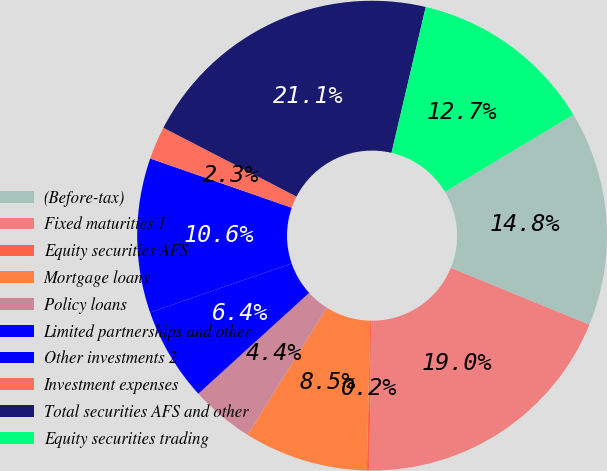<chart> <loc_0><loc_0><loc_500><loc_500><pie_chart><fcel>(Before-tax)<fcel>Fixed maturities 1<fcel>Equity securities AFS<fcel>Mortgage loans<fcel>Policy loans<fcel>Limited partnerships and other<fcel>Other investments 2<fcel>Investment expenses<fcel>Total securities AFS and other<fcel>Equity securities trading<nl><fcel>14.81%<fcel>18.99%<fcel>0.18%<fcel>8.54%<fcel>4.36%<fcel>6.45%<fcel>10.63%<fcel>2.27%<fcel>21.08%<fcel>12.72%<nl></chart> 